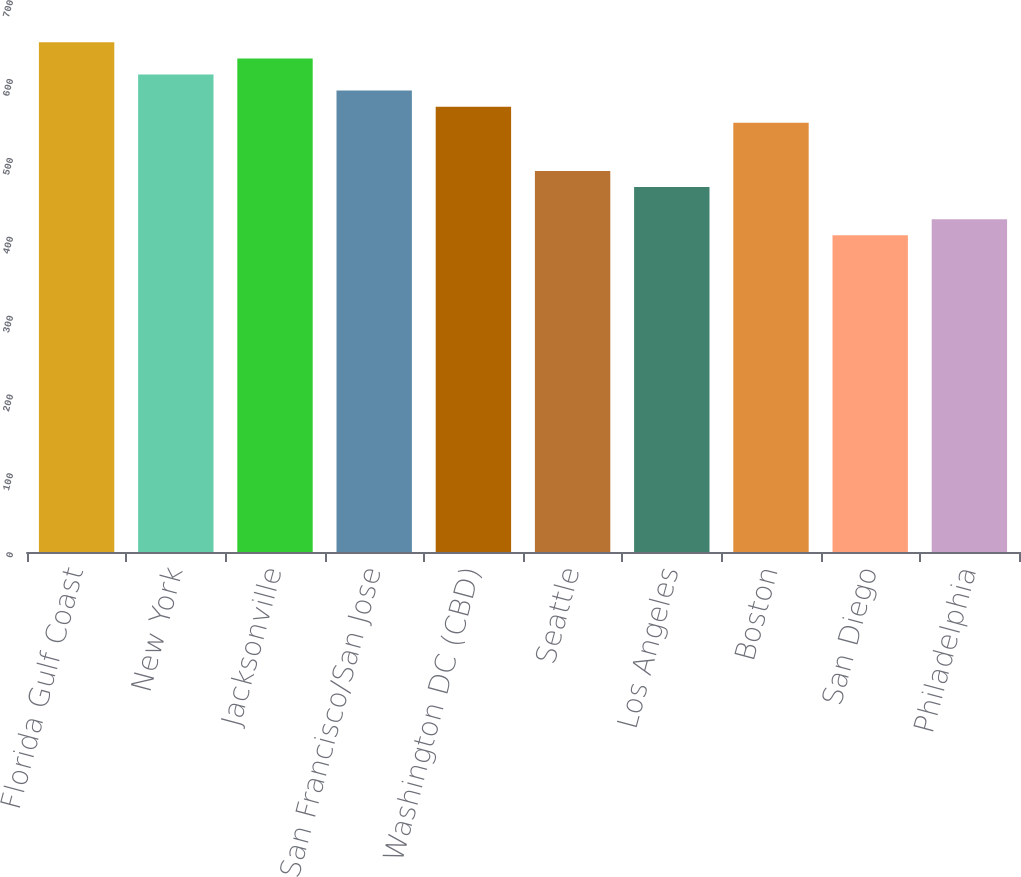Convert chart. <chart><loc_0><loc_0><loc_500><loc_500><bar_chart><fcel>Florida Gulf Coast<fcel>New York<fcel>Jacksonville<fcel>San Francisco/San Jose<fcel>Washington DC (CBD)<fcel>Seattle<fcel>Los Angeles<fcel>Boston<fcel>San Diego<fcel>Philadelphia<nl><fcel>646.27<fcel>605.51<fcel>625.89<fcel>585.13<fcel>564.75<fcel>483.23<fcel>462.85<fcel>544.37<fcel>401.71<fcel>422.09<nl></chart> 